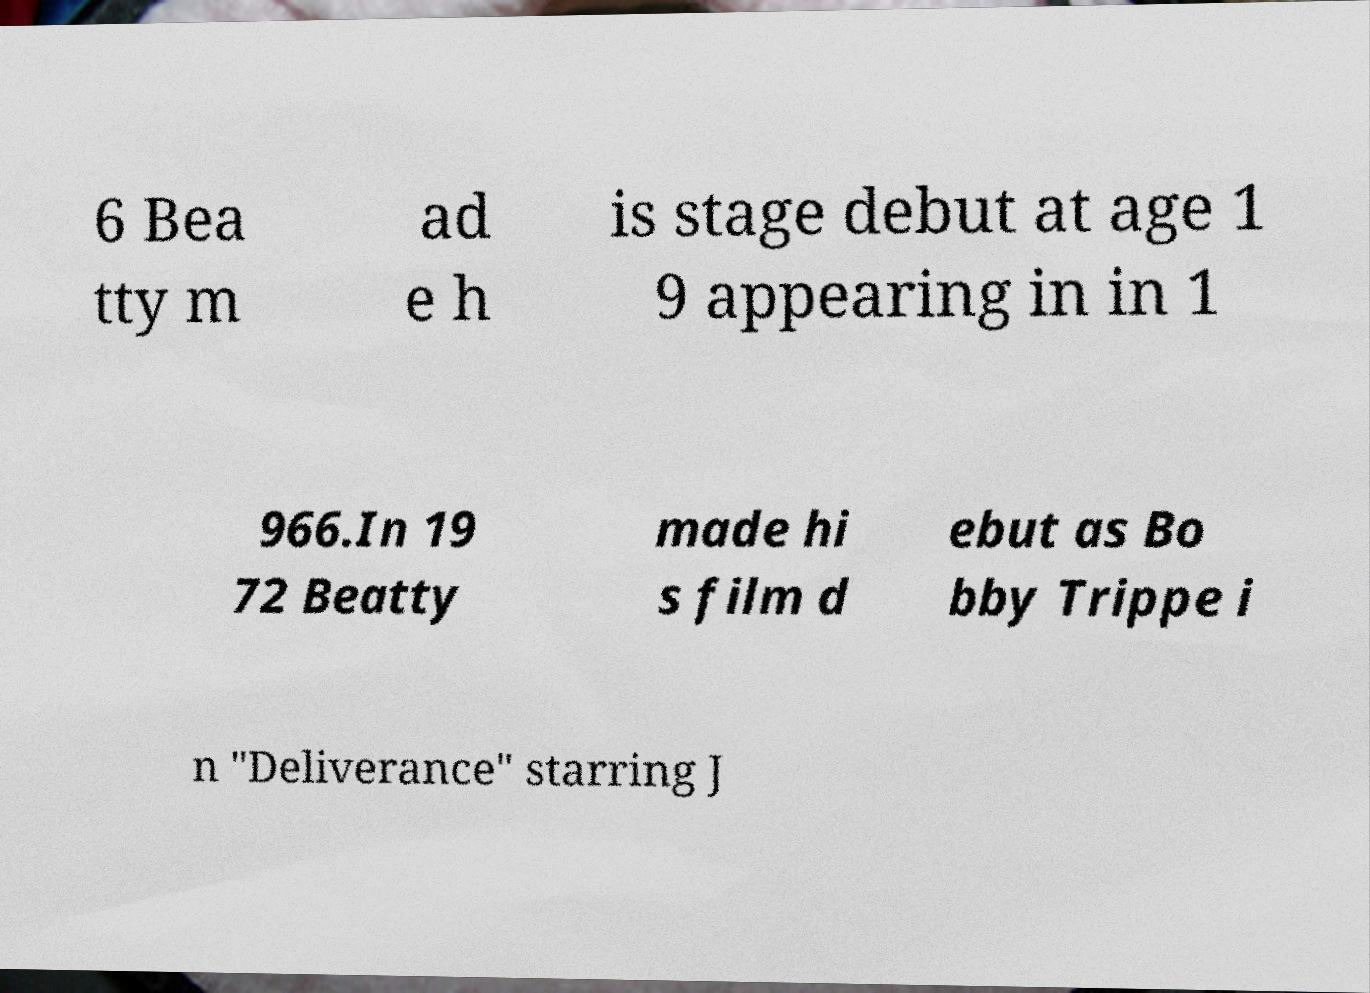Could you extract and type out the text from this image? 6 Bea tty m ad e h is stage debut at age 1 9 appearing in in 1 966.In 19 72 Beatty made hi s film d ebut as Bo bby Trippe i n "Deliverance" starring J 